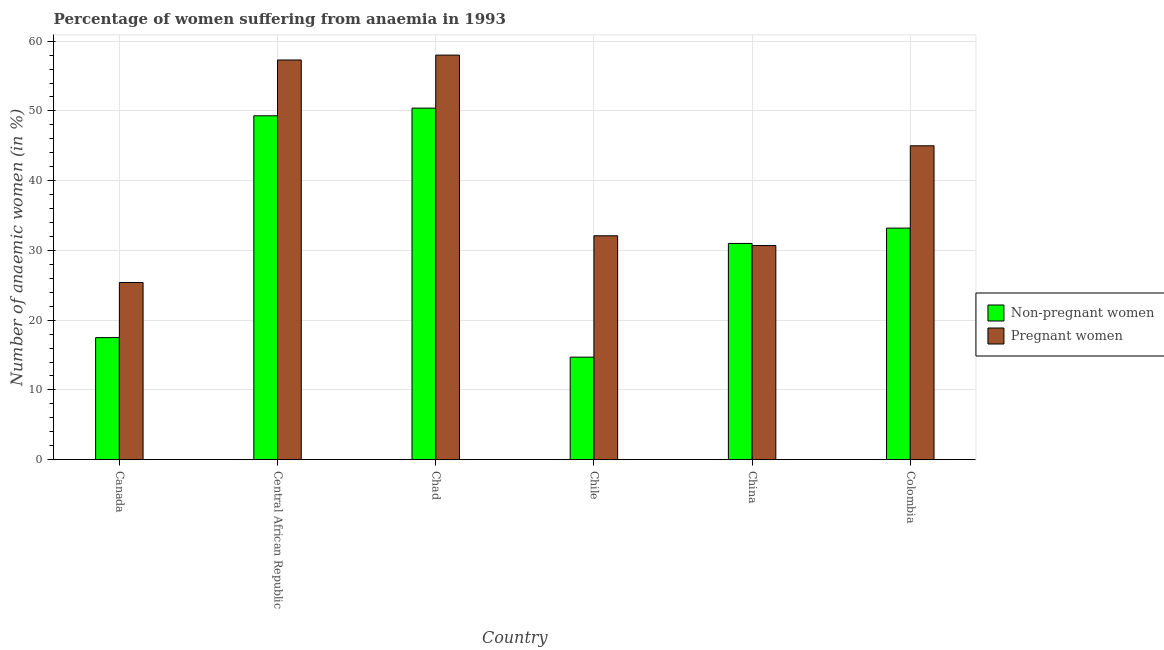How many groups of bars are there?
Provide a short and direct response. 6. Are the number of bars per tick equal to the number of legend labels?
Provide a succinct answer. Yes. How many bars are there on the 6th tick from the right?
Make the answer very short. 2. What is the label of the 2nd group of bars from the left?
Provide a short and direct response. Central African Republic. In how many cases, is the number of bars for a given country not equal to the number of legend labels?
Your answer should be very brief. 0. Across all countries, what is the minimum percentage of pregnant anaemic women?
Keep it short and to the point. 25.4. In which country was the percentage of pregnant anaemic women maximum?
Your response must be concise. Chad. What is the total percentage of non-pregnant anaemic women in the graph?
Offer a terse response. 196.1. What is the difference between the percentage of non-pregnant anaemic women in Central African Republic and that in Chile?
Your answer should be very brief. 34.6. What is the difference between the percentage of non-pregnant anaemic women in Canada and the percentage of pregnant anaemic women in Chile?
Offer a terse response. -14.6. What is the average percentage of non-pregnant anaemic women per country?
Provide a succinct answer. 32.68. What is the difference between the percentage of non-pregnant anaemic women and percentage of pregnant anaemic women in Chile?
Your answer should be compact. -17.4. In how many countries, is the percentage of non-pregnant anaemic women greater than 54 %?
Your response must be concise. 0. What is the ratio of the percentage of pregnant anaemic women in Central African Republic to that in China?
Offer a very short reply. 1.87. Is the percentage of non-pregnant anaemic women in Central African Republic less than that in Chad?
Give a very brief answer. Yes. Is the difference between the percentage of pregnant anaemic women in Canada and Central African Republic greater than the difference between the percentage of non-pregnant anaemic women in Canada and Central African Republic?
Give a very brief answer. No. What is the difference between the highest and the second highest percentage of non-pregnant anaemic women?
Your answer should be very brief. 1.1. What is the difference between the highest and the lowest percentage of pregnant anaemic women?
Make the answer very short. 32.6. What does the 2nd bar from the left in Central African Republic represents?
Provide a short and direct response. Pregnant women. What does the 1st bar from the right in Canada represents?
Offer a terse response. Pregnant women. How many bars are there?
Make the answer very short. 12. Are all the bars in the graph horizontal?
Offer a terse response. No. Does the graph contain grids?
Offer a very short reply. Yes. Where does the legend appear in the graph?
Keep it short and to the point. Center right. What is the title of the graph?
Offer a very short reply. Percentage of women suffering from anaemia in 1993. What is the label or title of the Y-axis?
Your answer should be compact. Number of anaemic women (in %). What is the Number of anaemic women (in %) in Non-pregnant women in Canada?
Provide a short and direct response. 17.5. What is the Number of anaemic women (in %) of Pregnant women in Canada?
Keep it short and to the point. 25.4. What is the Number of anaemic women (in %) in Non-pregnant women in Central African Republic?
Your response must be concise. 49.3. What is the Number of anaemic women (in %) of Pregnant women in Central African Republic?
Your response must be concise. 57.3. What is the Number of anaemic women (in %) of Non-pregnant women in Chad?
Your answer should be compact. 50.4. What is the Number of anaemic women (in %) of Pregnant women in Chad?
Offer a very short reply. 58. What is the Number of anaemic women (in %) in Non-pregnant women in Chile?
Your answer should be very brief. 14.7. What is the Number of anaemic women (in %) in Pregnant women in Chile?
Ensure brevity in your answer.  32.1. What is the Number of anaemic women (in %) in Pregnant women in China?
Offer a very short reply. 30.7. What is the Number of anaemic women (in %) in Non-pregnant women in Colombia?
Offer a very short reply. 33.2. What is the Number of anaemic women (in %) in Pregnant women in Colombia?
Provide a succinct answer. 45. Across all countries, what is the maximum Number of anaemic women (in %) of Non-pregnant women?
Keep it short and to the point. 50.4. Across all countries, what is the maximum Number of anaemic women (in %) in Pregnant women?
Offer a terse response. 58. Across all countries, what is the minimum Number of anaemic women (in %) in Pregnant women?
Your answer should be compact. 25.4. What is the total Number of anaemic women (in %) of Non-pregnant women in the graph?
Ensure brevity in your answer.  196.1. What is the total Number of anaemic women (in %) in Pregnant women in the graph?
Provide a succinct answer. 248.5. What is the difference between the Number of anaemic women (in %) in Non-pregnant women in Canada and that in Central African Republic?
Offer a terse response. -31.8. What is the difference between the Number of anaemic women (in %) in Pregnant women in Canada and that in Central African Republic?
Give a very brief answer. -31.9. What is the difference between the Number of anaemic women (in %) of Non-pregnant women in Canada and that in Chad?
Make the answer very short. -32.9. What is the difference between the Number of anaemic women (in %) in Pregnant women in Canada and that in Chad?
Provide a short and direct response. -32.6. What is the difference between the Number of anaemic women (in %) of Pregnant women in Canada and that in Chile?
Give a very brief answer. -6.7. What is the difference between the Number of anaemic women (in %) of Non-pregnant women in Canada and that in China?
Your answer should be very brief. -13.5. What is the difference between the Number of anaemic women (in %) in Pregnant women in Canada and that in China?
Ensure brevity in your answer.  -5.3. What is the difference between the Number of anaemic women (in %) of Non-pregnant women in Canada and that in Colombia?
Your response must be concise. -15.7. What is the difference between the Number of anaemic women (in %) of Pregnant women in Canada and that in Colombia?
Ensure brevity in your answer.  -19.6. What is the difference between the Number of anaemic women (in %) in Non-pregnant women in Central African Republic and that in Chad?
Your answer should be very brief. -1.1. What is the difference between the Number of anaemic women (in %) of Pregnant women in Central African Republic and that in Chad?
Ensure brevity in your answer.  -0.7. What is the difference between the Number of anaemic women (in %) in Non-pregnant women in Central African Republic and that in Chile?
Provide a succinct answer. 34.6. What is the difference between the Number of anaemic women (in %) in Pregnant women in Central African Republic and that in Chile?
Ensure brevity in your answer.  25.2. What is the difference between the Number of anaemic women (in %) in Non-pregnant women in Central African Republic and that in China?
Offer a terse response. 18.3. What is the difference between the Number of anaemic women (in %) of Pregnant women in Central African Republic and that in China?
Offer a very short reply. 26.6. What is the difference between the Number of anaemic women (in %) in Pregnant women in Central African Republic and that in Colombia?
Provide a succinct answer. 12.3. What is the difference between the Number of anaemic women (in %) of Non-pregnant women in Chad and that in Chile?
Offer a terse response. 35.7. What is the difference between the Number of anaemic women (in %) in Pregnant women in Chad and that in Chile?
Make the answer very short. 25.9. What is the difference between the Number of anaemic women (in %) of Pregnant women in Chad and that in China?
Your answer should be compact. 27.3. What is the difference between the Number of anaemic women (in %) in Non-pregnant women in Chad and that in Colombia?
Your response must be concise. 17.2. What is the difference between the Number of anaemic women (in %) of Non-pregnant women in Chile and that in China?
Keep it short and to the point. -16.3. What is the difference between the Number of anaemic women (in %) of Pregnant women in Chile and that in China?
Ensure brevity in your answer.  1.4. What is the difference between the Number of anaemic women (in %) of Non-pregnant women in Chile and that in Colombia?
Keep it short and to the point. -18.5. What is the difference between the Number of anaemic women (in %) of Pregnant women in China and that in Colombia?
Ensure brevity in your answer.  -14.3. What is the difference between the Number of anaemic women (in %) of Non-pregnant women in Canada and the Number of anaemic women (in %) of Pregnant women in Central African Republic?
Keep it short and to the point. -39.8. What is the difference between the Number of anaemic women (in %) of Non-pregnant women in Canada and the Number of anaemic women (in %) of Pregnant women in Chad?
Your response must be concise. -40.5. What is the difference between the Number of anaemic women (in %) of Non-pregnant women in Canada and the Number of anaemic women (in %) of Pregnant women in Chile?
Ensure brevity in your answer.  -14.6. What is the difference between the Number of anaemic women (in %) in Non-pregnant women in Canada and the Number of anaemic women (in %) in Pregnant women in China?
Ensure brevity in your answer.  -13.2. What is the difference between the Number of anaemic women (in %) in Non-pregnant women in Canada and the Number of anaemic women (in %) in Pregnant women in Colombia?
Provide a short and direct response. -27.5. What is the difference between the Number of anaemic women (in %) in Non-pregnant women in Central African Republic and the Number of anaemic women (in %) in Pregnant women in Chad?
Keep it short and to the point. -8.7. What is the difference between the Number of anaemic women (in %) of Non-pregnant women in Central African Republic and the Number of anaemic women (in %) of Pregnant women in Chile?
Offer a very short reply. 17.2. What is the difference between the Number of anaemic women (in %) in Non-pregnant women in Central African Republic and the Number of anaemic women (in %) in Pregnant women in China?
Keep it short and to the point. 18.6. What is the difference between the Number of anaemic women (in %) in Non-pregnant women in Chad and the Number of anaemic women (in %) in Pregnant women in Chile?
Provide a succinct answer. 18.3. What is the difference between the Number of anaemic women (in %) in Non-pregnant women in Chad and the Number of anaemic women (in %) in Pregnant women in China?
Give a very brief answer. 19.7. What is the difference between the Number of anaemic women (in %) in Non-pregnant women in Chile and the Number of anaemic women (in %) in Pregnant women in Colombia?
Provide a succinct answer. -30.3. What is the average Number of anaemic women (in %) of Non-pregnant women per country?
Provide a succinct answer. 32.68. What is the average Number of anaemic women (in %) of Pregnant women per country?
Give a very brief answer. 41.42. What is the difference between the Number of anaemic women (in %) of Non-pregnant women and Number of anaemic women (in %) of Pregnant women in Canada?
Your answer should be compact. -7.9. What is the difference between the Number of anaemic women (in %) of Non-pregnant women and Number of anaemic women (in %) of Pregnant women in Central African Republic?
Ensure brevity in your answer.  -8. What is the difference between the Number of anaemic women (in %) in Non-pregnant women and Number of anaemic women (in %) in Pregnant women in Chad?
Your response must be concise. -7.6. What is the difference between the Number of anaemic women (in %) of Non-pregnant women and Number of anaemic women (in %) of Pregnant women in Chile?
Your response must be concise. -17.4. What is the difference between the Number of anaemic women (in %) in Non-pregnant women and Number of anaemic women (in %) in Pregnant women in China?
Provide a short and direct response. 0.3. What is the ratio of the Number of anaemic women (in %) of Non-pregnant women in Canada to that in Central African Republic?
Ensure brevity in your answer.  0.35. What is the ratio of the Number of anaemic women (in %) in Pregnant women in Canada to that in Central African Republic?
Make the answer very short. 0.44. What is the ratio of the Number of anaemic women (in %) in Non-pregnant women in Canada to that in Chad?
Ensure brevity in your answer.  0.35. What is the ratio of the Number of anaemic women (in %) in Pregnant women in Canada to that in Chad?
Offer a very short reply. 0.44. What is the ratio of the Number of anaemic women (in %) of Non-pregnant women in Canada to that in Chile?
Offer a terse response. 1.19. What is the ratio of the Number of anaemic women (in %) in Pregnant women in Canada to that in Chile?
Your answer should be very brief. 0.79. What is the ratio of the Number of anaemic women (in %) in Non-pregnant women in Canada to that in China?
Your answer should be compact. 0.56. What is the ratio of the Number of anaemic women (in %) in Pregnant women in Canada to that in China?
Your answer should be compact. 0.83. What is the ratio of the Number of anaemic women (in %) of Non-pregnant women in Canada to that in Colombia?
Provide a short and direct response. 0.53. What is the ratio of the Number of anaemic women (in %) of Pregnant women in Canada to that in Colombia?
Provide a short and direct response. 0.56. What is the ratio of the Number of anaemic women (in %) in Non-pregnant women in Central African Republic to that in Chad?
Offer a terse response. 0.98. What is the ratio of the Number of anaemic women (in %) in Pregnant women in Central African Republic to that in Chad?
Provide a short and direct response. 0.99. What is the ratio of the Number of anaemic women (in %) of Non-pregnant women in Central African Republic to that in Chile?
Offer a very short reply. 3.35. What is the ratio of the Number of anaemic women (in %) in Pregnant women in Central African Republic to that in Chile?
Your answer should be compact. 1.78. What is the ratio of the Number of anaemic women (in %) in Non-pregnant women in Central African Republic to that in China?
Ensure brevity in your answer.  1.59. What is the ratio of the Number of anaemic women (in %) in Pregnant women in Central African Republic to that in China?
Provide a succinct answer. 1.87. What is the ratio of the Number of anaemic women (in %) in Non-pregnant women in Central African Republic to that in Colombia?
Your answer should be very brief. 1.48. What is the ratio of the Number of anaemic women (in %) in Pregnant women in Central African Republic to that in Colombia?
Ensure brevity in your answer.  1.27. What is the ratio of the Number of anaemic women (in %) in Non-pregnant women in Chad to that in Chile?
Offer a terse response. 3.43. What is the ratio of the Number of anaemic women (in %) in Pregnant women in Chad to that in Chile?
Provide a succinct answer. 1.81. What is the ratio of the Number of anaemic women (in %) of Non-pregnant women in Chad to that in China?
Ensure brevity in your answer.  1.63. What is the ratio of the Number of anaemic women (in %) of Pregnant women in Chad to that in China?
Make the answer very short. 1.89. What is the ratio of the Number of anaemic women (in %) in Non-pregnant women in Chad to that in Colombia?
Your response must be concise. 1.52. What is the ratio of the Number of anaemic women (in %) in Pregnant women in Chad to that in Colombia?
Keep it short and to the point. 1.29. What is the ratio of the Number of anaemic women (in %) in Non-pregnant women in Chile to that in China?
Your answer should be compact. 0.47. What is the ratio of the Number of anaemic women (in %) of Pregnant women in Chile to that in China?
Make the answer very short. 1.05. What is the ratio of the Number of anaemic women (in %) in Non-pregnant women in Chile to that in Colombia?
Offer a very short reply. 0.44. What is the ratio of the Number of anaemic women (in %) in Pregnant women in Chile to that in Colombia?
Make the answer very short. 0.71. What is the ratio of the Number of anaemic women (in %) of Non-pregnant women in China to that in Colombia?
Your answer should be very brief. 0.93. What is the ratio of the Number of anaemic women (in %) in Pregnant women in China to that in Colombia?
Keep it short and to the point. 0.68. What is the difference between the highest and the second highest Number of anaemic women (in %) of Non-pregnant women?
Keep it short and to the point. 1.1. What is the difference between the highest and the second highest Number of anaemic women (in %) in Pregnant women?
Provide a short and direct response. 0.7. What is the difference between the highest and the lowest Number of anaemic women (in %) of Non-pregnant women?
Offer a terse response. 35.7. What is the difference between the highest and the lowest Number of anaemic women (in %) in Pregnant women?
Your answer should be compact. 32.6. 